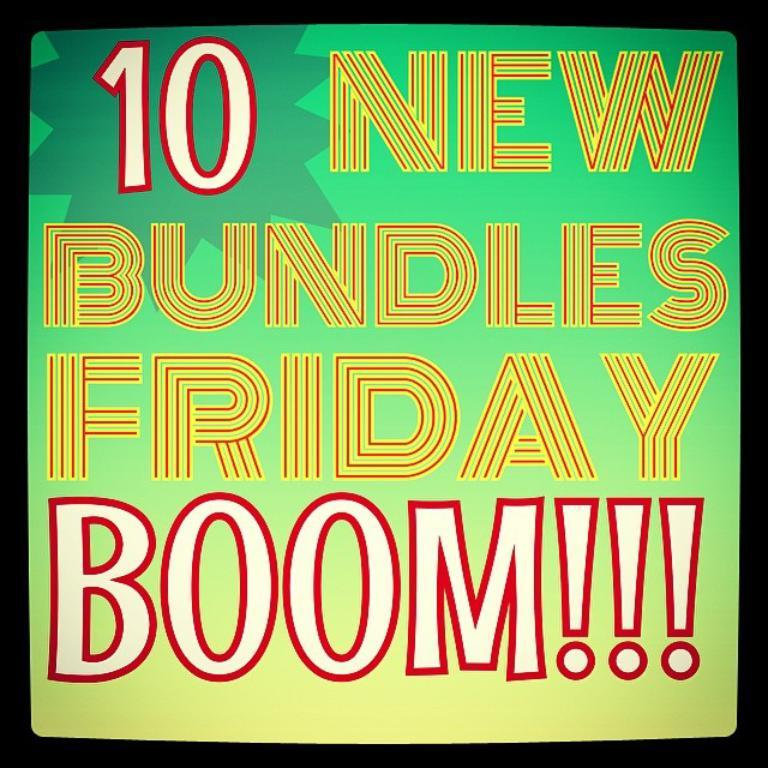<image>
Render a clear and concise summary of the photo. A green and yellow sign that advertises 10 New Bundles Friday 